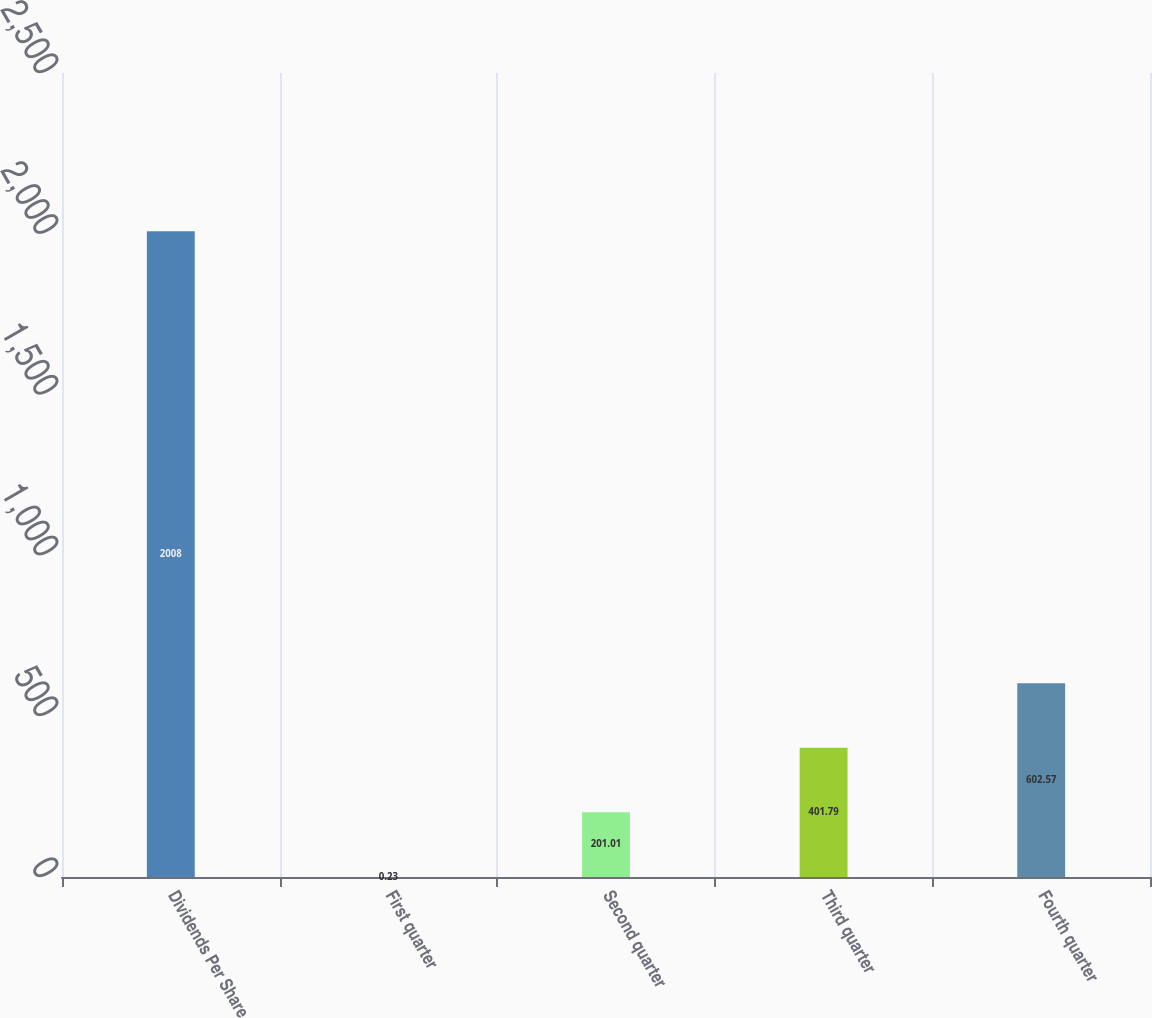<chart> <loc_0><loc_0><loc_500><loc_500><bar_chart><fcel>Dividends Per Share<fcel>First quarter<fcel>Second quarter<fcel>Third quarter<fcel>Fourth quarter<nl><fcel>2008<fcel>0.23<fcel>201.01<fcel>401.79<fcel>602.57<nl></chart> 